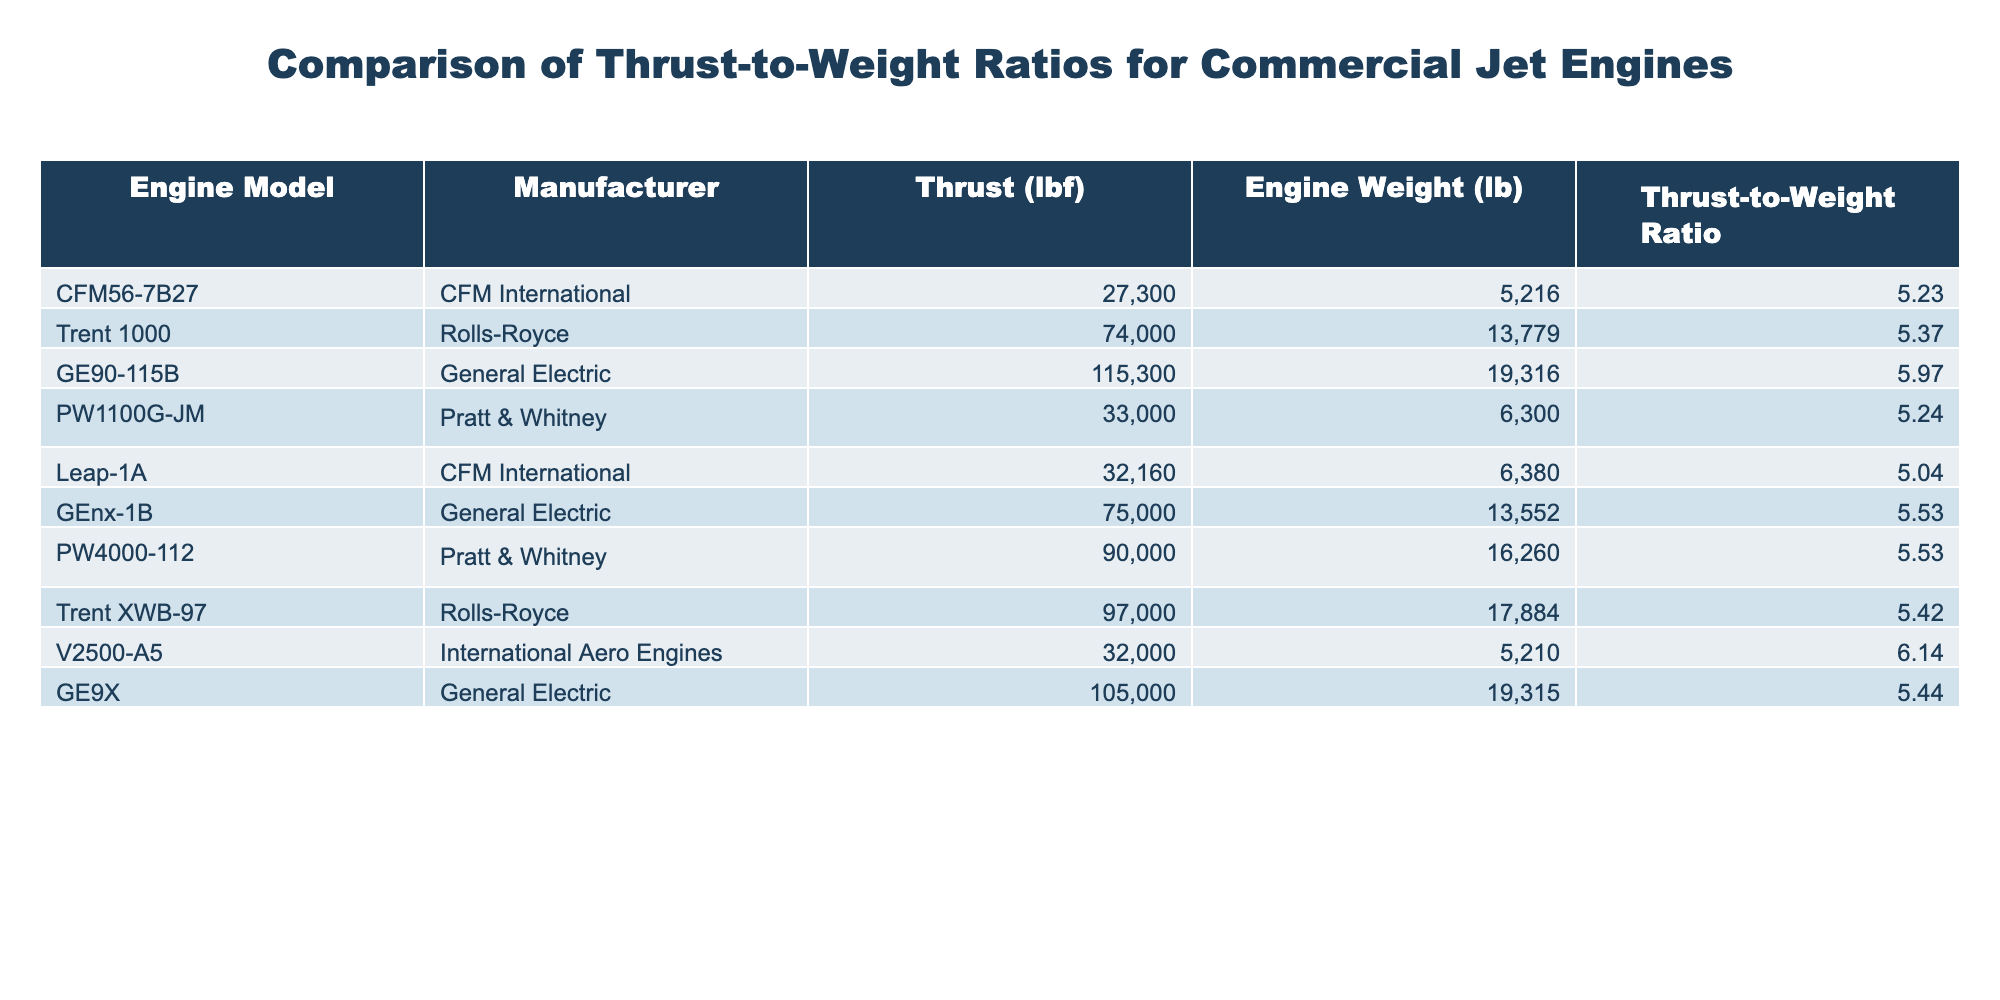What is the thrust-to-weight ratio of the GE90-115B engine? The table indicates that the thrust-to-weight ratio for the GE90-115B engine is listed in the corresponding row under that engine model. The value is found to be 5.97.
Answer: 5.97 Which engine model has the highest thrust-to-weight ratio? By comparing the thrust-to-weight ratios from each engine model in the table, it is clear that the V2500-A5 has the highest value of 6.14.
Answer: V2500-A5 What is the average thrust-to-weight ratio of the engines manufactured by General Electric? For General Electric, the thrust-to-weight ratios of the GE90-115B (5.97), GEnx-1B (5.53), and GE9X (5.44) are considered. The sum of these values is 5.97 + 5.53 + 5.44 = 16.94. Dividing by 3 (the total number of engines) gives an average of 16.94/3 = 5.65.
Answer: 5.65 Is the thrust-to-weight ratio of the Trent 1000 higher than that of the PW4000-112? The thrust-to-weight ratio for the Trent 1000 is 5.37, and for the PW4000-112 it is 5.53. Since 5.37 < 5.53, the statement is false.
Answer: No What is the difference in thrust-to-weight ratios between the Leap-1A and PW1100G-JM engines? The thrust-to-weight ratio for the Leap-1A is 5.04 and for the PW1100G-JM is 5.24. The difference is calculated as 5.24 - 5.04 = 0.20.
Answer: 0.20 How many engines have a thrust-to-weight ratio greater than 5.50? By reviewing the thrust-to-weight ratios in the table, the engines with ratios greater than 5.50 are: Trent 1000 (5.37), GEnx-1B (5.53), PW4000-112 (5.53), Trent XWB-97 (5.42), and V2500-A5 (6.14). That makes a total of 5 engines.
Answer: 5 Which manufacturer has the engine with the lowest thrust-to-weight ratio? The engine with the lowest thrust-to-weight ratio is the Leap-1A from CFM International, with a ratio of 5.04, found directly in the table.
Answer: CFM International 